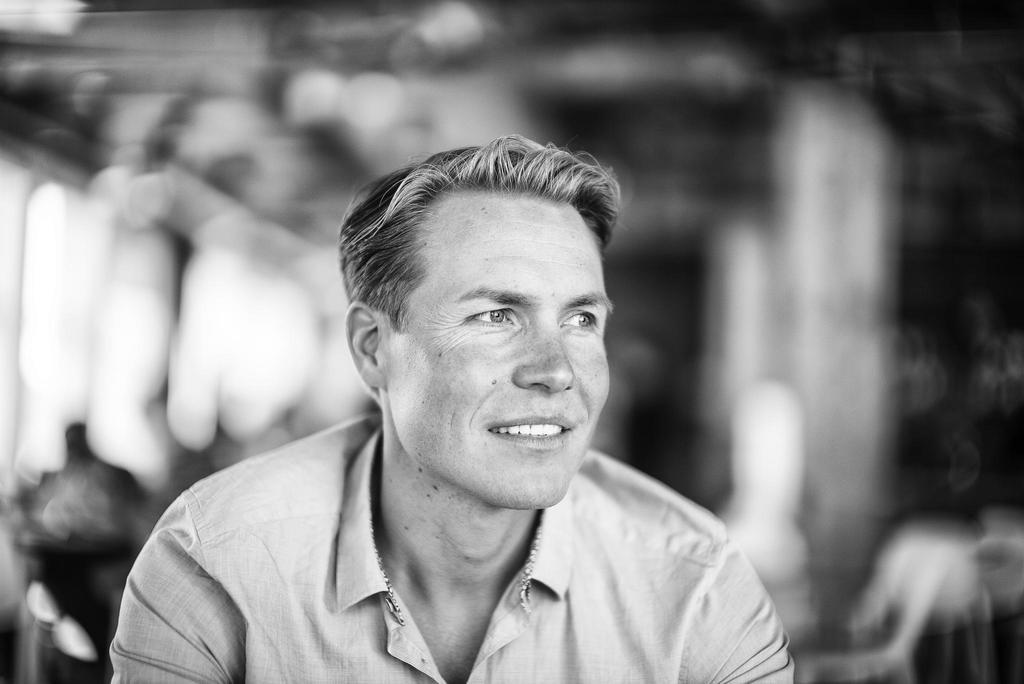Can you describe this image briefly? In this image, we can see a man sitting and he is smiling, there is a blur background. 